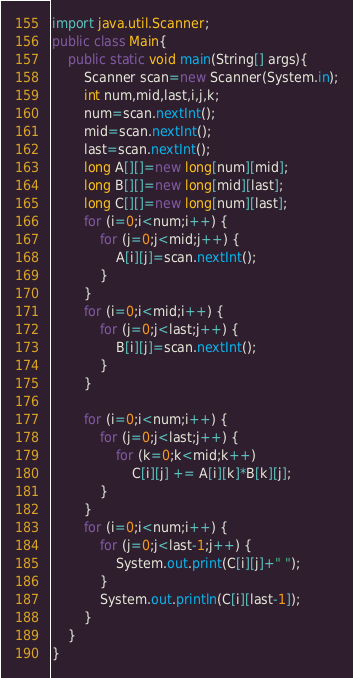<code> <loc_0><loc_0><loc_500><loc_500><_Java_>import java.util.Scanner;
public class Main{
    public static void main(String[] args){
        Scanner scan=new Scanner(System.in);
        int num,mid,last,i,j,k;
        num=scan.nextInt();
        mid=scan.nextInt();
        last=scan.nextInt();
        long A[][]=new long[num][mid];
        long B[][]=new long[mid][last];
        long C[][]=new long[num][last];
        for (i=0;i<num;i++) { 
            for (j=0;j<mid;j++) { 
                A[i][j]=scan.nextInt();
            } 
        } 
        for (i=0;i<mid;i++) { 
            for (j=0;j<last;j++) { 
                B[i][j]=scan.nextInt();
            } 
        }
        
        for (i=0;i<num;i++) { 
            for (j=0;j<last;j++) { 
                for (k=0;k<mid;k++) 
                    C[i][j] += A[i][k]*B[k][j]; 
            } 
        } 
        for (i=0;i<num;i++) { 
            for (j=0;j<last-1;j++) {
                System.out.print(C[i][j]+" ");
            }
            System.out.println(C[i][last-1]);
        } 
    }
}
</code> 